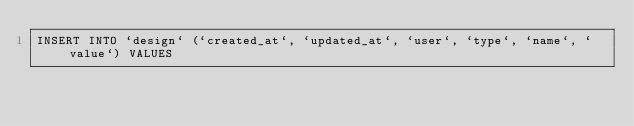<code> <loc_0><loc_0><loc_500><loc_500><_SQL_>INSERT INTO `design` (`created_at`, `updated_at`, `user`, `type`, `name`, `value`) VALUES </code> 